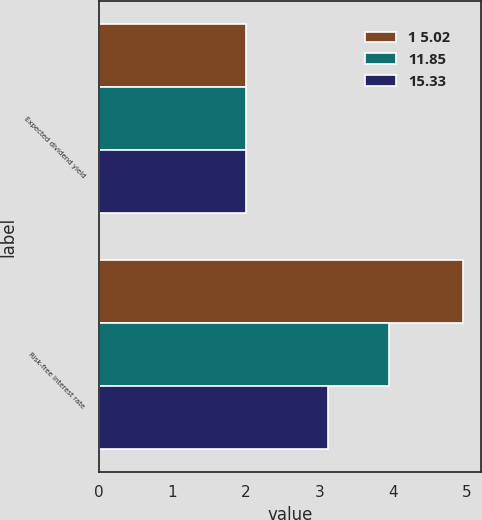Convert chart to OTSL. <chart><loc_0><loc_0><loc_500><loc_500><stacked_bar_chart><ecel><fcel>Expected dividend yield<fcel>Risk-free interest rate<nl><fcel>1 5.02<fcel>2<fcel>4.95<nl><fcel>11.85<fcel>2<fcel>3.95<nl><fcel>15.33<fcel>2<fcel>3.11<nl></chart> 